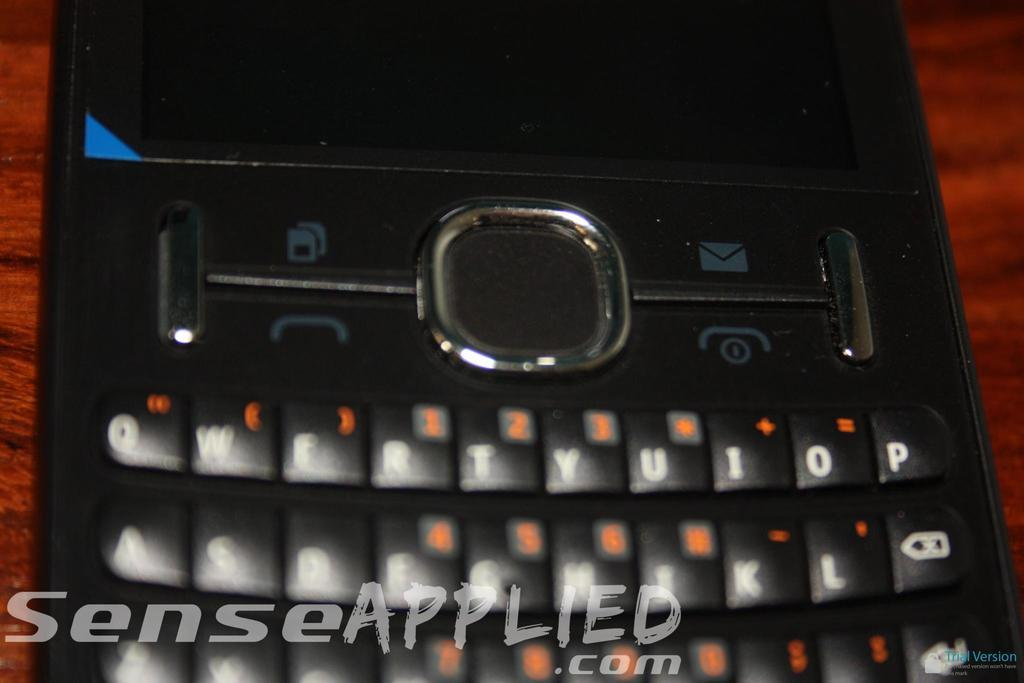What is the main object in the image? There is a mobile in the image. On what surface is the mobile placed? The mobile is placed on a wooden surface. What can be found on the mobile's key buttons? The mobile's key buttons have letters and numbers. What is present at the bottom of the image? There is edited text at the bottom of the image. Can you tell me how many people are streaming a joke in the image? There is no reference to people streaming a joke in the image; it features a mobile with letters and numbers on its key buttons and edited text at the bottom. 